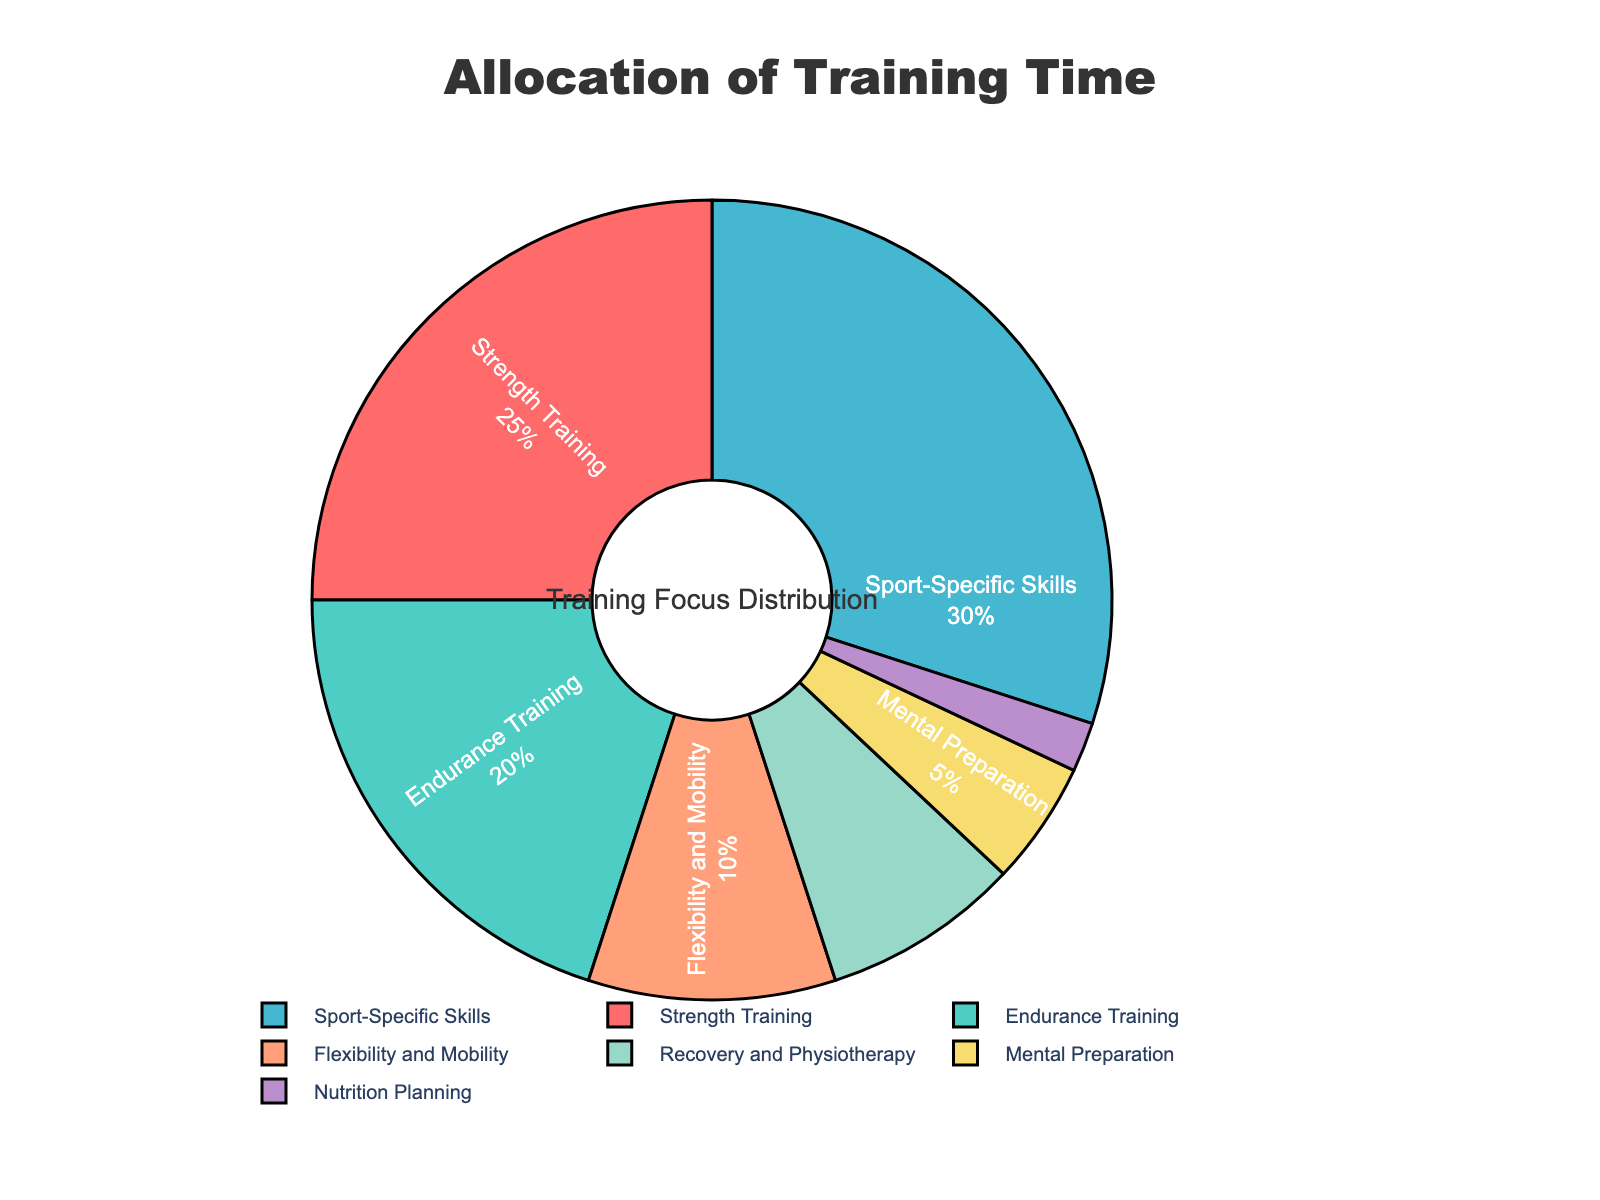What is the percentage of time allocated to Endurance Training? Look at the slice labeled "Endurance Training" and refer to its percentage value.
Answer: 20% Which aspect has the smallest allocation of training time? Find the slice with the smallest percentage value.
Answer: Nutrition Planning What is the difference in percentage between Strength Training and Flexibility and Mobility? Subtract the percentage of Flexibility and Mobility from Strength Training (25 - 10).
Answer: 15% How much more training time is allocated to Sport-Specific Skills compared to Mental Preparation? Subtract the percentage of Mental Preparation from Sport-Specific Skills (30 - 5).
Answer: 25% What is the combined percentage for Recovery and Physiotherapy and Flexibility and Mobility? Add the percentages of Recovery and Physiotherapy and Flexibility and Mobility (8 + 10).
Answer: 18% Which aspect has a greater allocation: Nutrition Planning or Mental Preparation? Compare the percentage values of Nutrition Planning and Mental Preparation.
Answer: Mental Preparation Looking at the colors, which aspect is represented by the green slice? Identify the green slice and refer to its label.
Answer: Endurance Training Is the allocation for Strength Training more than Recovery and Physiotherapy plus Mental Preparation combined? Add Recovery and Physiotherapy (8%) and Mental Preparation (5%) to get 13%, and compare with Strength Training (25%).
Answer: Yes What fraction of the training time is devoted to Nutrition Planning? The slice for Nutrition Planning represents 2% of the whole, which as a fraction is 2/100 or 1/50.
Answer: 1/50 